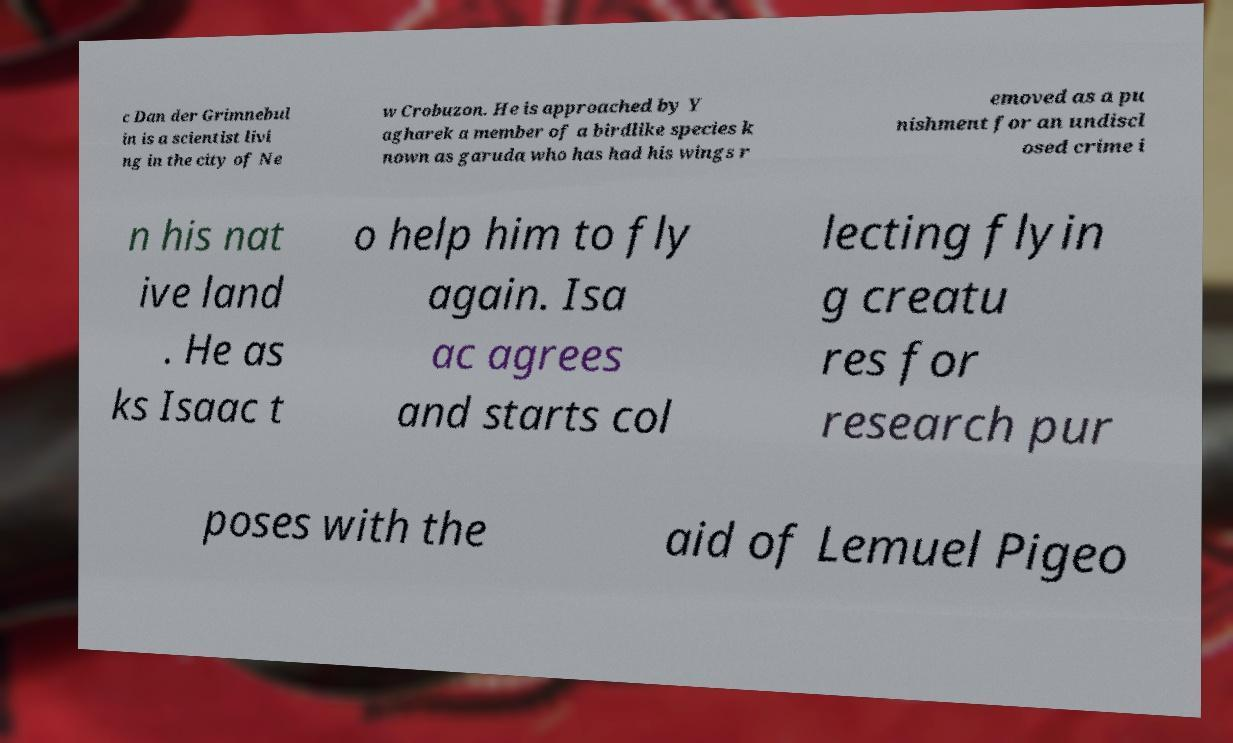What messages or text are displayed in this image? I need them in a readable, typed format. c Dan der Grimnebul in is a scientist livi ng in the city of Ne w Crobuzon. He is approached by Y agharek a member of a birdlike species k nown as garuda who has had his wings r emoved as a pu nishment for an undiscl osed crime i n his nat ive land . He as ks Isaac t o help him to fly again. Isa ac agrees and starts col lecting flyin g creatu res for research pur poses with the aid of Lemuel Pigeo 